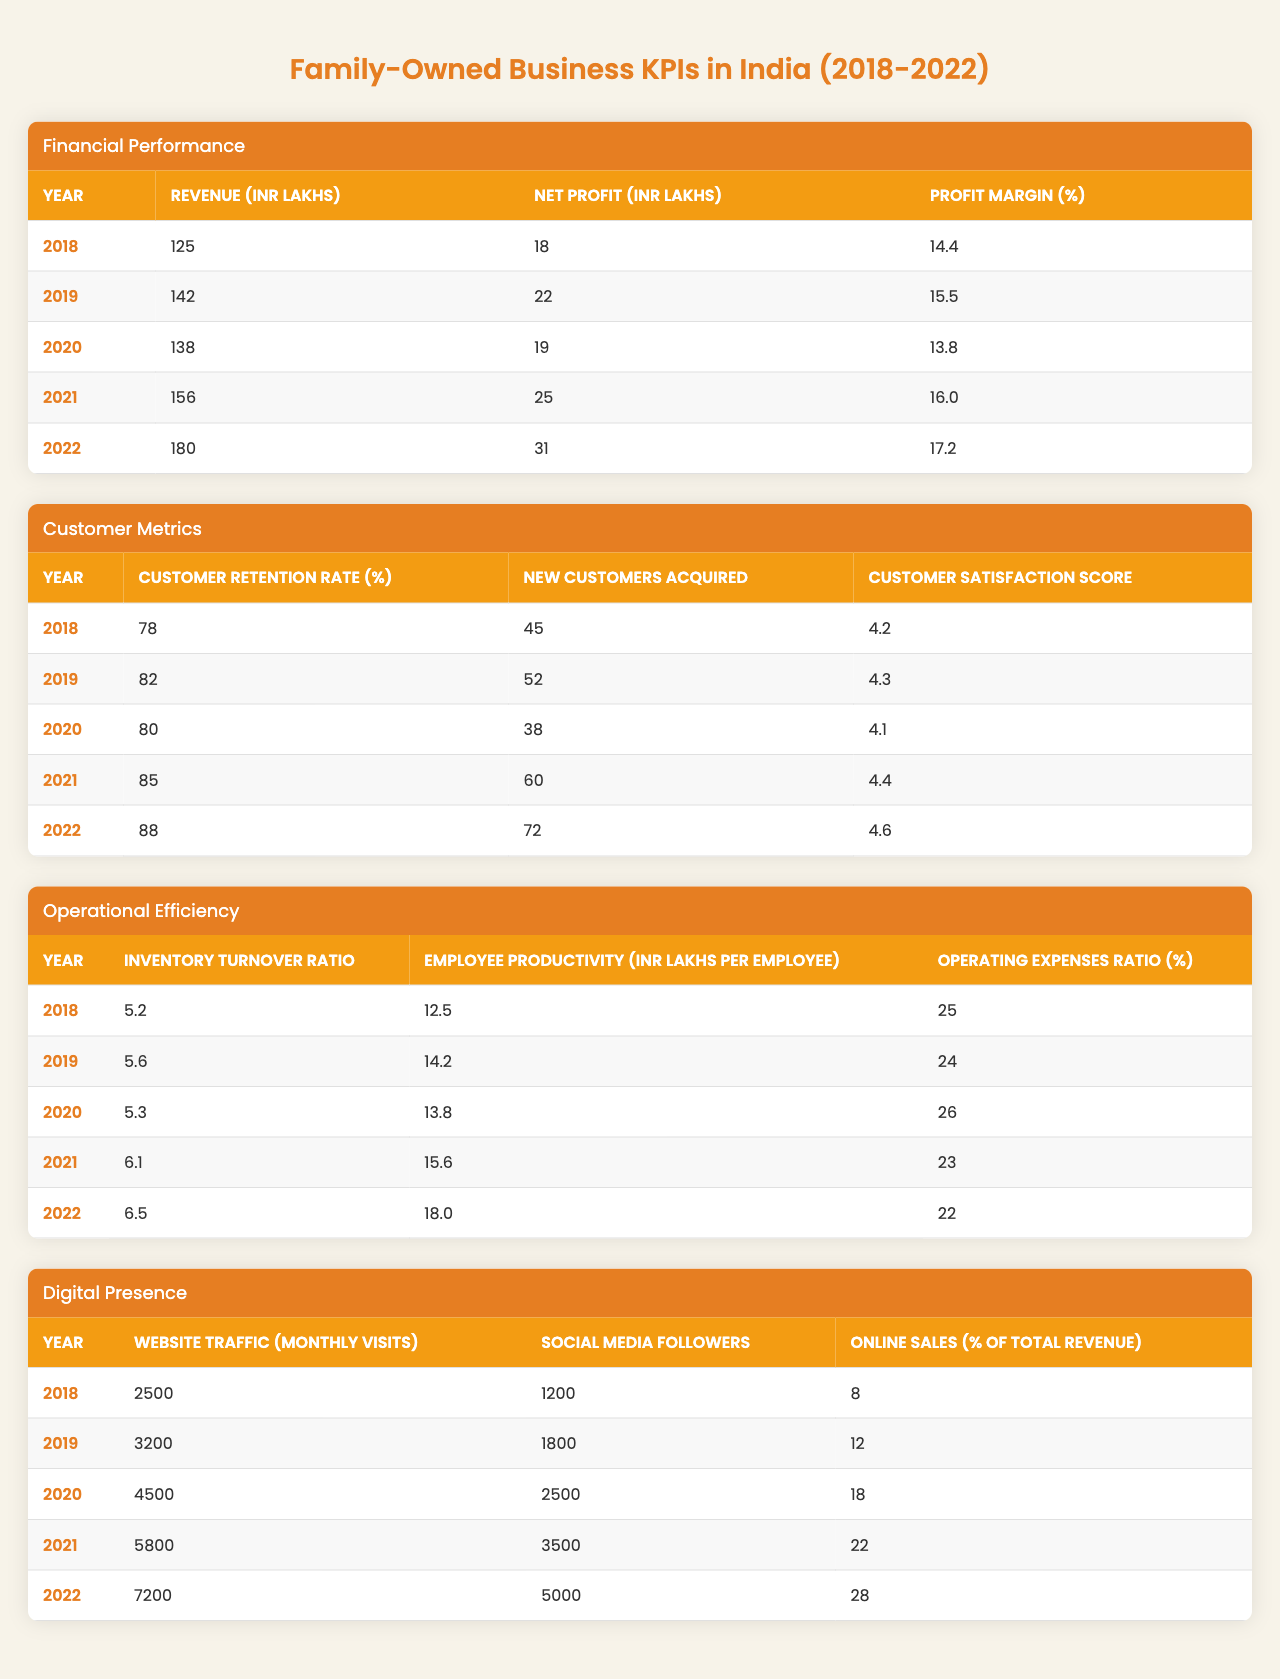What was the net profit in 2021? The table lists the net profit for the year 2021 as 25 INR Lakhs.
Answer: 25 INR Lakhs Which year had the highest revenue? By comparing the revenue for each year, 2022 shows the highest revenue of 180 INR Lakhs.
Answer: 2022 What is the average profit margin over the five years? The profit margins from 2018 to 2022 are: 14.4%, 15.5%, 13.8%, 16.0%, and 17.2%. The sum is 77.0%, and the average is 77.0%/5 = 15.4%.
Answer: 15.4% Did the customer retention rate increase every year? Checking the customer retention rates from 2018 (78%) to 2022 (88%), it increased every year: 78%, 82%, 80%, 85%, 88%.
Answer: Yes What was the change in online sales percentage from 2018 to 2022? The online sales percentage in 2018 was 8%, and in 2022 it was 28%. The change is 28% - 8% = 20%.
Answer: 20% Calculate the total net profit over the five years. The net profits for each year are 18, 22, 19, 25, and 31. Adding them gives: 18 + 22 + 19 + 25 + 31 = 115 INR Lakhs.
Answer: 115 INR Lakhs Which year had the lowest employee productivity? From the data, employee productivity was lowest in 2018 with 12.5 INR Lakhs per employee.
Answer: 2018 Is the inventory turnover ratio increasing consistently? The ratios are 5.2, 5.6, 5.3, 6.1, and 6.5. It increased consistently from 2018 to 2019, then decreased in 2020, and increased thereafter, showing inconsistency.
Answer: No What was the customer satisfaction score in 2020 and how does it compare to 2021? The customer satisfaction score in 2020 was 4.1, and in 2021 it was 4.4. Comparing the two shows an increase of 0.3.
Answer: Increased by 0.3 What is the ratio of new customers acquired in 2022 to those acquired in 2019? New customers acquired in 2022 was 72 and in 2019 was 52. The ratio is 72/52 = 1.38 (approximately).
Answer: 1.38 